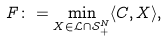Convert formula to latex. <formula><loc_0><loc_0><loc_500><loc_500>F \colon = \min _ { X \in \mathcal { L } \cap \mathcal { S } ^ { N } _ { + } } \langle C , X \rangle ,</formula> 